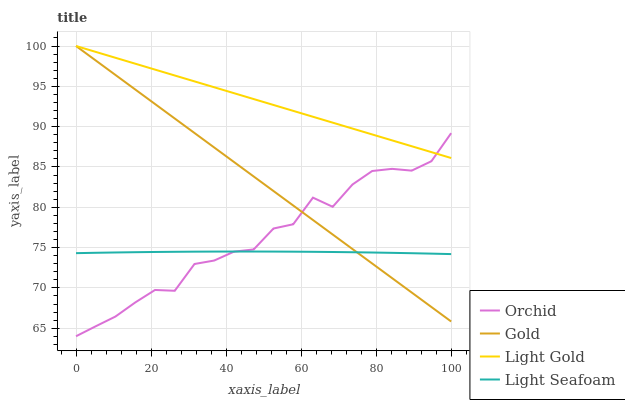Does Light Seafoam have the minimum area under the curve?
Answer yes or no. Yes. Does Light Gold have the maximum area under the curve?
Answer yes or no. Yes. Does Gold have the minimum area under the curve?
Answer yes or no. No. Does Gold have the maximum area under the curve?
Answer yes or no. No. Is Gold the smoothest?
Answer yes or no. Yes. Is Orchid the roughest?
Answer yes or no. Yes. Is Light Gold the smoothest?
Answer yes or no. No. Is Light Gold the roughest?
Answer yes or no. No. Does Orchid have the lowest value?
Answer yes or no. Yes. Does Gold have the lowest value?
Answer yes or no. No. Does Gold have the highest value?
Answer yes or no. Yes. Does Orchid have the highest value?
Answer yes or no. No. Is Light Seafoam less than Light Gold?
Answer yes or no. Yes. Is Light Gold greater than Light Seafoam?
Answer yes or no. Yes. Does Light Seafoam intersect Orchid?
Answer yes or no. Yes. Is Light Seafoam less than Orchid?
Answer yes or no. No. Is Light Seafoam greater than Orchid?
Answer yes or no. No. Does Light Seafoam intersect Light Gold?
Answer yes or no. No. 